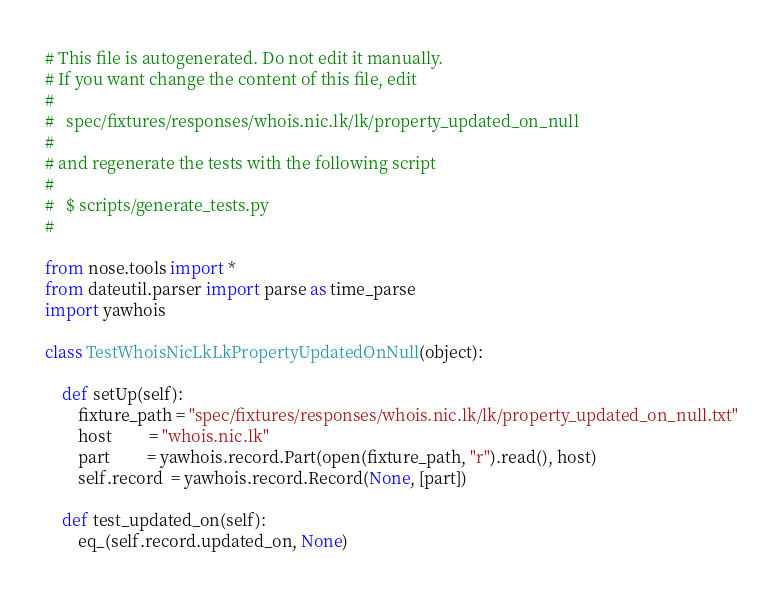<code> <loc_0><loc_0><loc_500><loc_500><_Python_>
# This file is autogenerated. Do not edit it manually.
# If you want change the content of this file, edit
#
#   spec/fixtures/responses/whois.nic.lk/lk/property_updated_on_null
#
# and regenerate the tests with the following script
#
#   $ scripts/generate_tests.py
#

from nose.tools import *
from dateutil.parser import parse as time_parse
import yawhois

class TestWhoisNicLkLkPropertyUpdatedOnNull(object):

    def setUp(self):
        fixture_path = "spec/fixtures/responses/whois.nic.lk/lk/property_updated_on_null.txt"
        host         = "whois.nic.lk"
        part         = yawhois.record.Part(open(fixture_path, "r").read(), host)
        self.record  = yawhois.record.Record(None, [part])

    def test_updated_on(self):
        eq_(self.record.updated_on, None)
</code> 